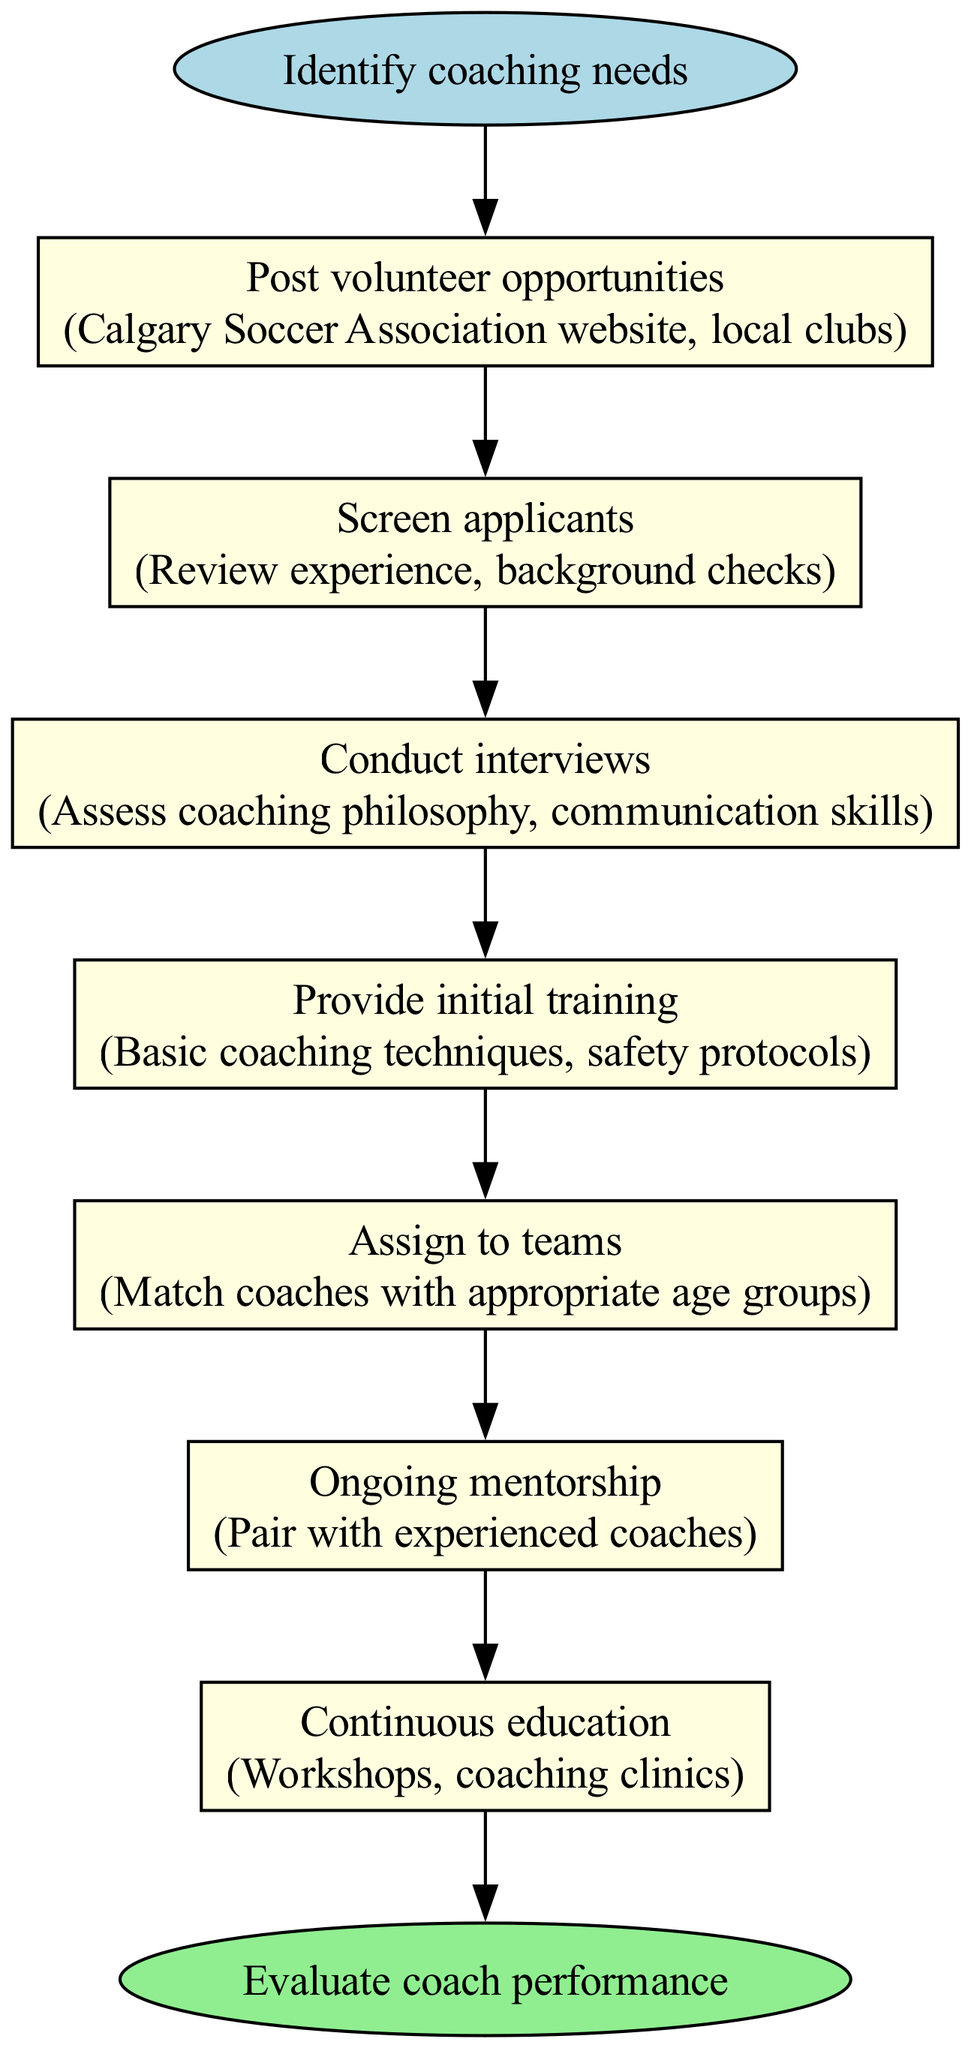What is the first step in the process? The diagram starts with the "Identify coaching needs" node, which is the first step indicated.
Answer: Identify coaching needs How many steps are there in total? The steps section lists seven individual steps, so by counting them, we find there are seven steps in total.
Answer: 7 What is the last step before evaluation? The last step before the evaluation of coach performance is "Continuous education," which is the final node before the end.
Answer: Continuous education Which step involves assessing coaching philosophy? The "Conduct interviews" step involves assessing the coaching philosophy, as noted in the details associated with that step.
Answer: Conduct interviews What is assigned to teams? In the process, the step "Assign to teams" indicates that coaches are matched with appropriate age groups, which is what is being assigned.
Answer: Coaches How does the volunteer process start? The process starts with "Identify coaching needs," which is the initiating action of the flow chart.
Answer: Identify coaching needs What type of training is provided initially? The step "Provide initial training" details that basic coaching techniques and safety protocols are the focus of the initial training provided.
Answer: Basic coaching techniques, safety protocols What indicates the end of the process? The end of the process is marked by the "Evaluate coach performance" node, which is visually distinguished as the endpoint of the flow chart.
Answer: Evaluate coach performance Which step pairs new coaches with experienced ones? The "Ongoing mentorship" step pairs new coaches with experienced coaches, ensuring they receive guidance throughout their coaching journey.
Answer: Ongoing mentorship 